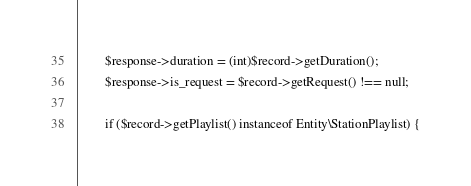Convert code to text. <code><loc_0><loc_0><loc_500><loc_500><_PHP_>        $response->duration = (int)$record->getDuration();
        $response->is_request = $record->getRequest() !== null;

        if ($record->getPlaylist() instanceof Entity\StationPlaylist) {</code> 